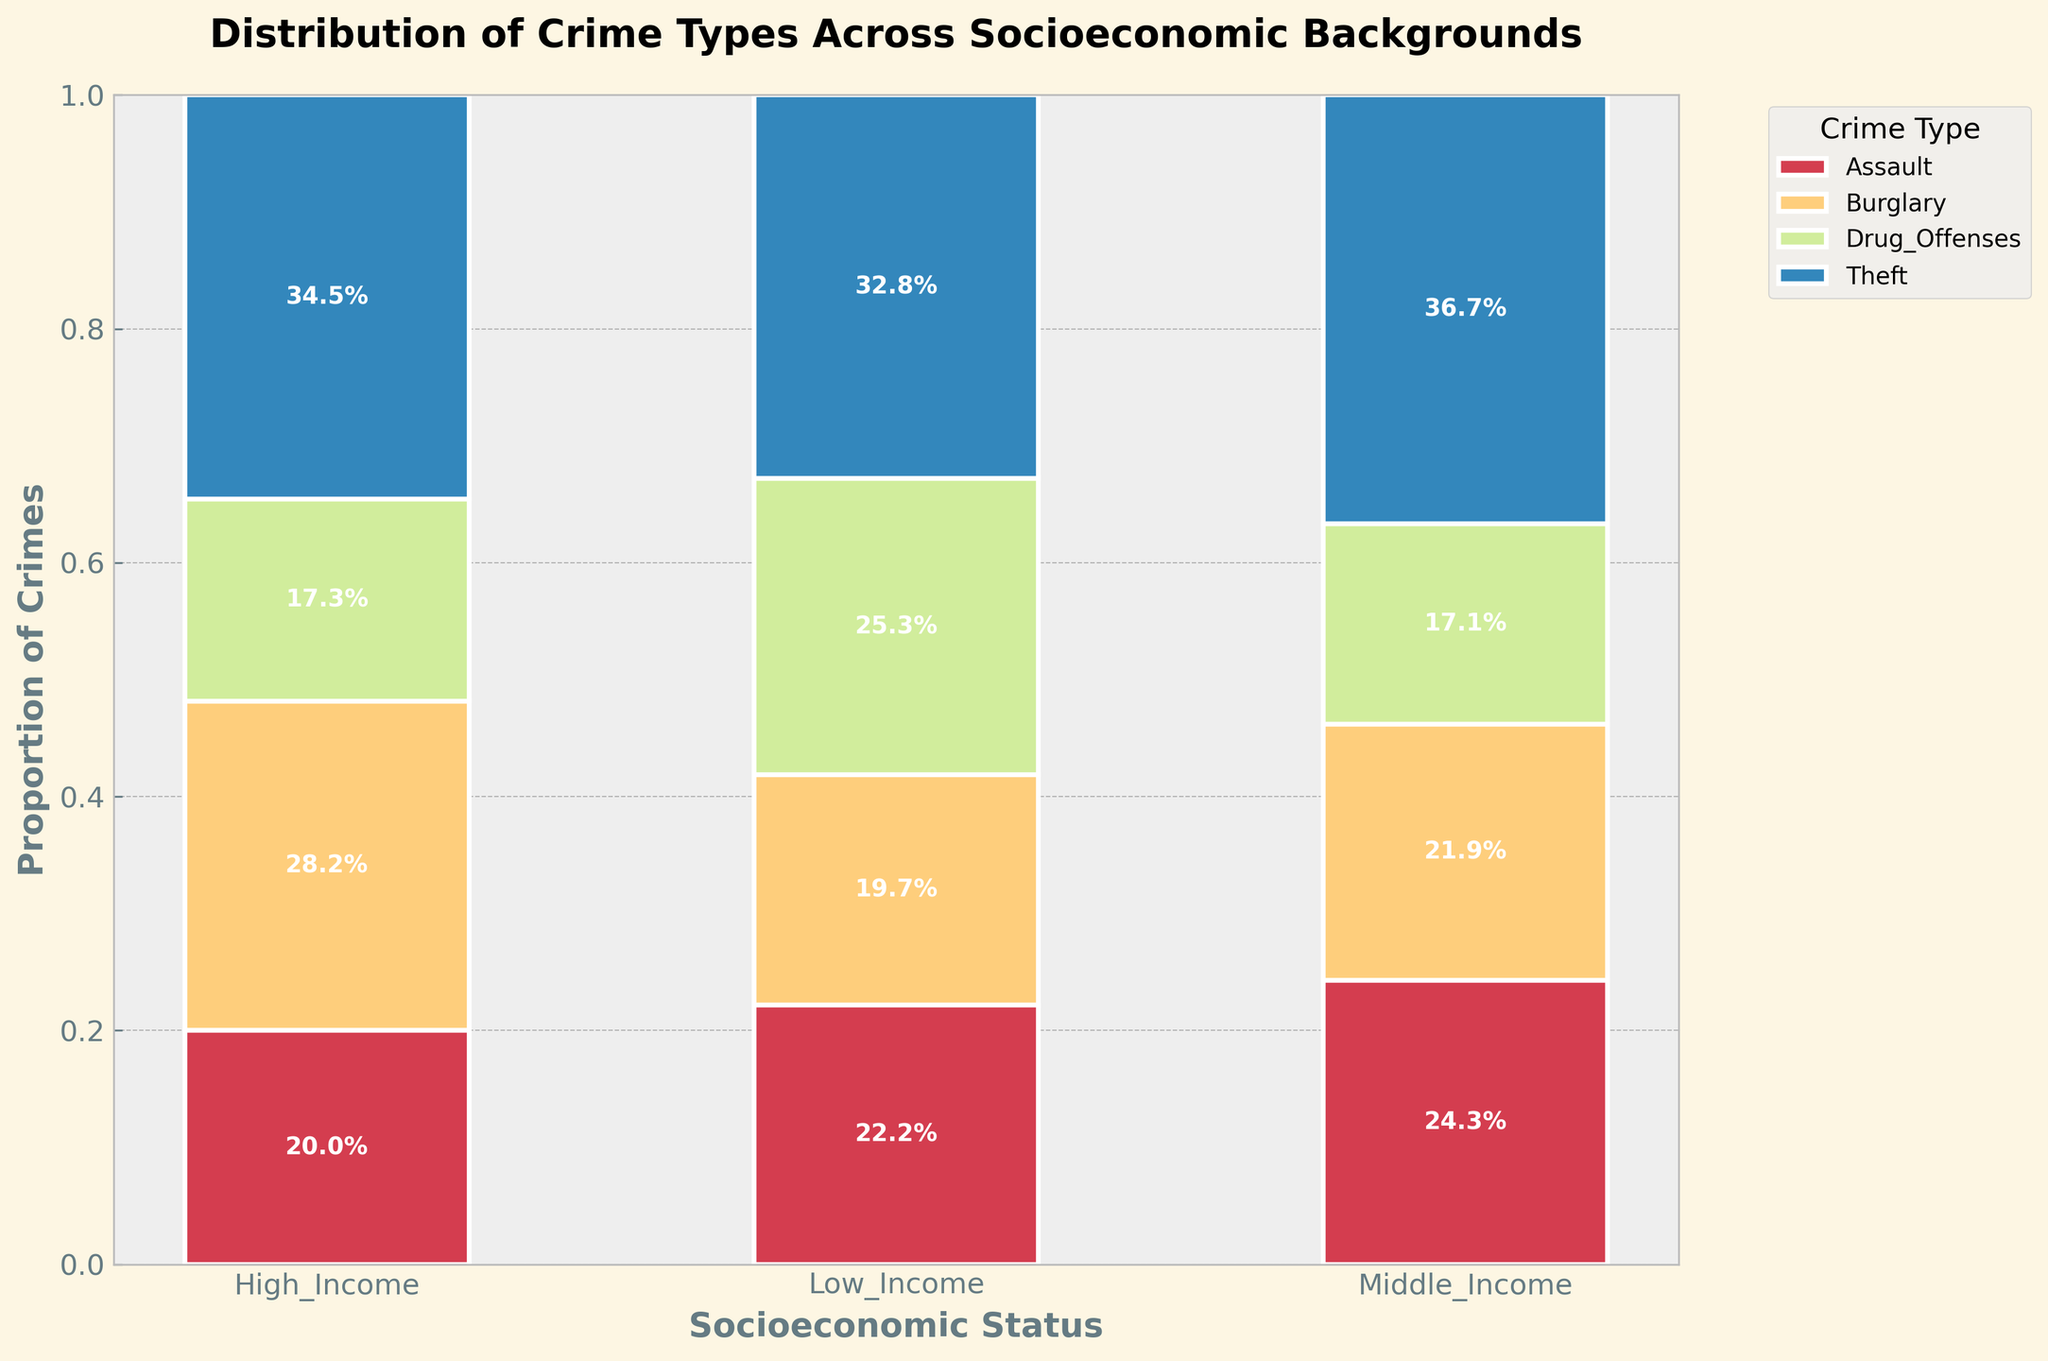How many different crime types are presented in the plot? The plot shows different colored sections representing the crime types. By counting the distinct color sections in the legend, we can determine that there are four crime types.
Answer: Four Which socioeconomic status has the highest proportion of Theft crimes? The width of each bar section and its label represent proportions. For each socioeconomic status, identify the section labeled "Theft" and compare the sizes. The Low Income section is the widest for Theft.
Answer: Low Income What is the proportion of Drug Offenses in High Income areas? Locate the bar for High Income and identify the section for Drug Offenses. The label inside the section indicates the proportion.
Answer: 16.2% Compare the proportions of Assault crimes between Low Income and Middle Income groups. Identify the sections for Assault in both Low Income and Middle Income bars, then compare their sizes and labels.
Answer: Low Income has a higher proportion of Assault than Middle Income Which socioeconomic status has the smallest proportion of Burglary crimes? Examine the bar sections labeled "Burglary" for each socioeconomic status. The one with the smallest section is High Income.
Answer: High Income Add the proportions of Theft and Drug Offenses in Middle Income areas. Locate the bar for Middle Income, identify the sections for Theft and Drug Offenses, and sum their proportions: 44.4% (Theft) + 20.8% (Drug Offenses).
Answer: 65.2% What percentage of the total crime is comprised of Assault in Low Income areas? Find the Assault section within the Low Income bar and check the labeled percentage.
Answer: 27.9% In which socioeconomic status is the proportion of Burglary higher: Low Income or High Income? Compare the sizes and labels of the Burglary sections in Low Income and High Income bars.
Answer: High Income Determine the sum of proportions for all crime types in Middle Income areas. Verify visually that the entire bar equals 100%, as it's a stacked bar representing complete proportions for each status.
Answer: 100% Which crime type shows the most consistent proportion across all socioeconomic statuses? Examine the sections for each crime type across all status bars and determine which one has the least variation in width.
Answer: Theft 